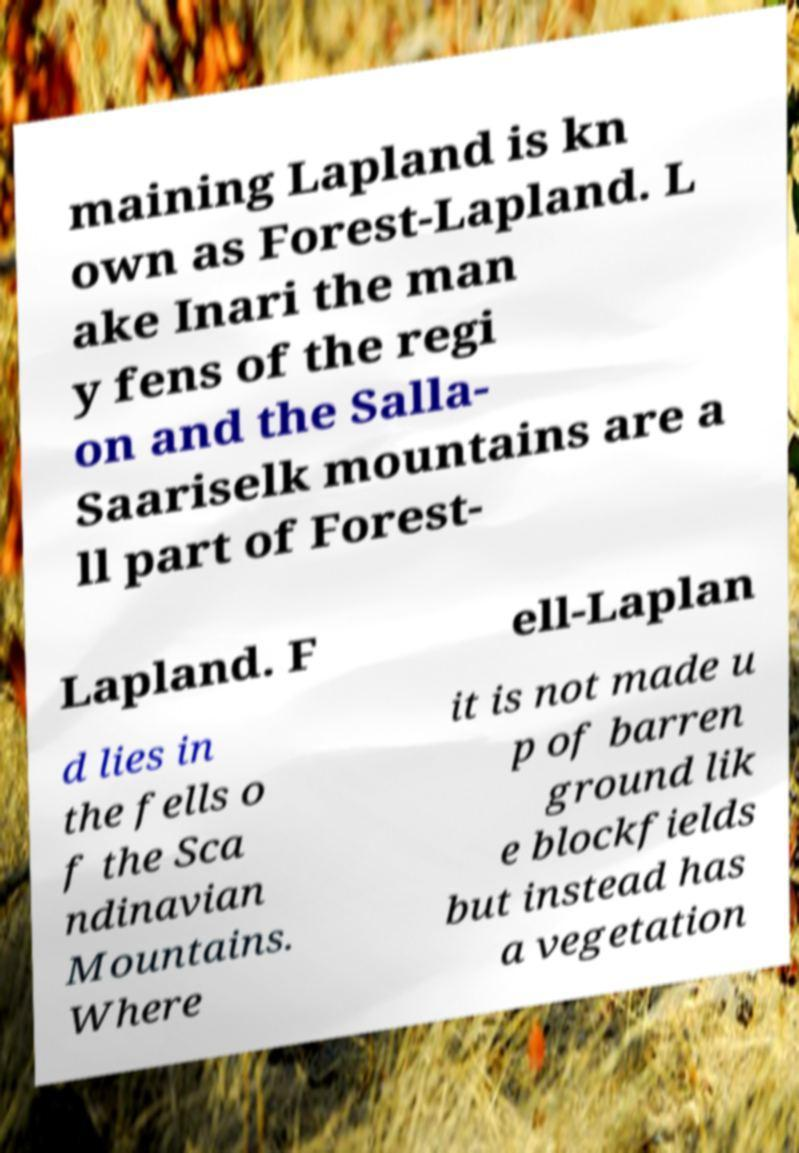Please read and relay the text visible in this image. What does it say? maining Lapland is kn own as Forest-Lapland. L ake Inari the man y fens of the regi on and the Salla- Saariselk mountains are a ll part of Forest- Lapland. F ell-Laplan d lies in the fells o f the Sca ndinavian Mountains. Where it is not made u p of barren ground lik e blockfields but instead has a vegetation 